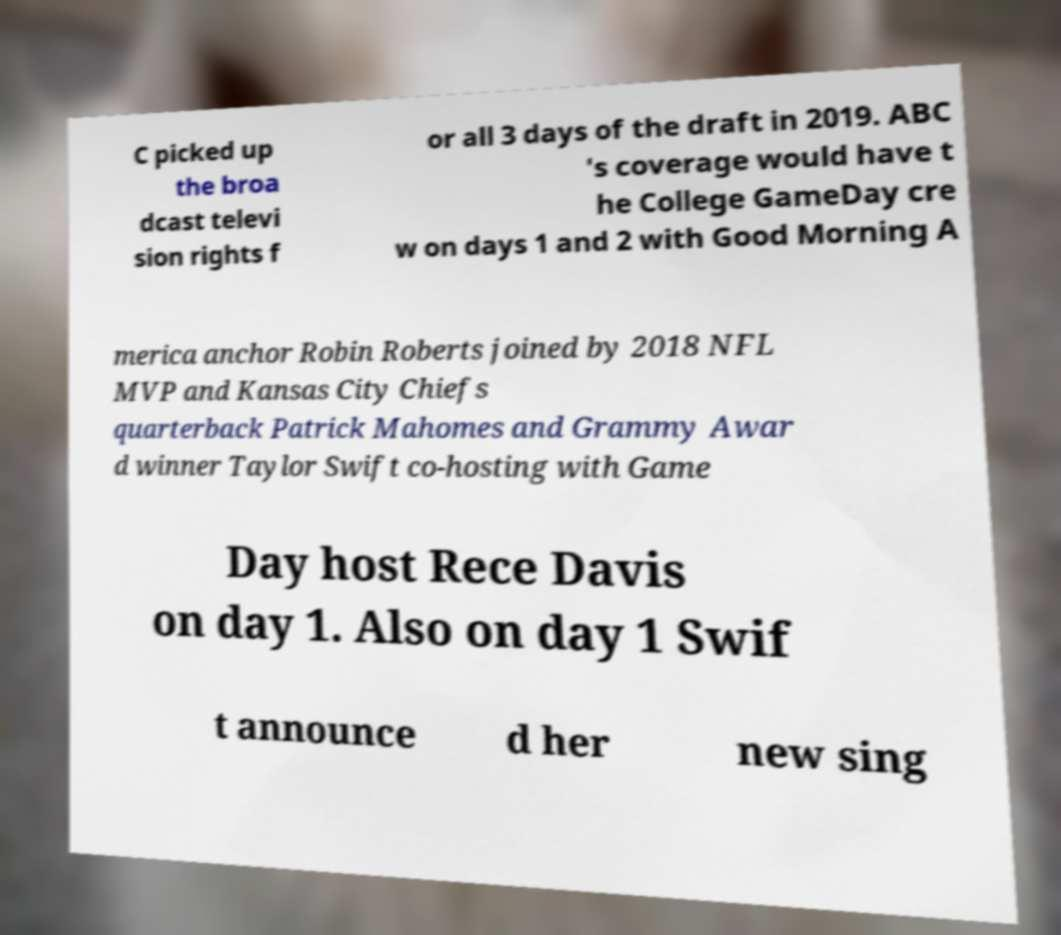I need the written content from this picture converted into text. Can you do that? C picked up the broa dcast televi sion rights f or all 3 days of the draft in 2019. ABC 's coverage would have t he College GameDay cre w on days 1 and 2 with Good Morning A merica anchor Robin Roberts joined by 2018 NFL MVP and Kansas City Chiefs quarterback Patrick Mahomes and Grammy Awar d winner Taylor Swift co-hosting with Game Day host Rece Davis on day 1. Also on day 1 Swif t announce d her new sing 